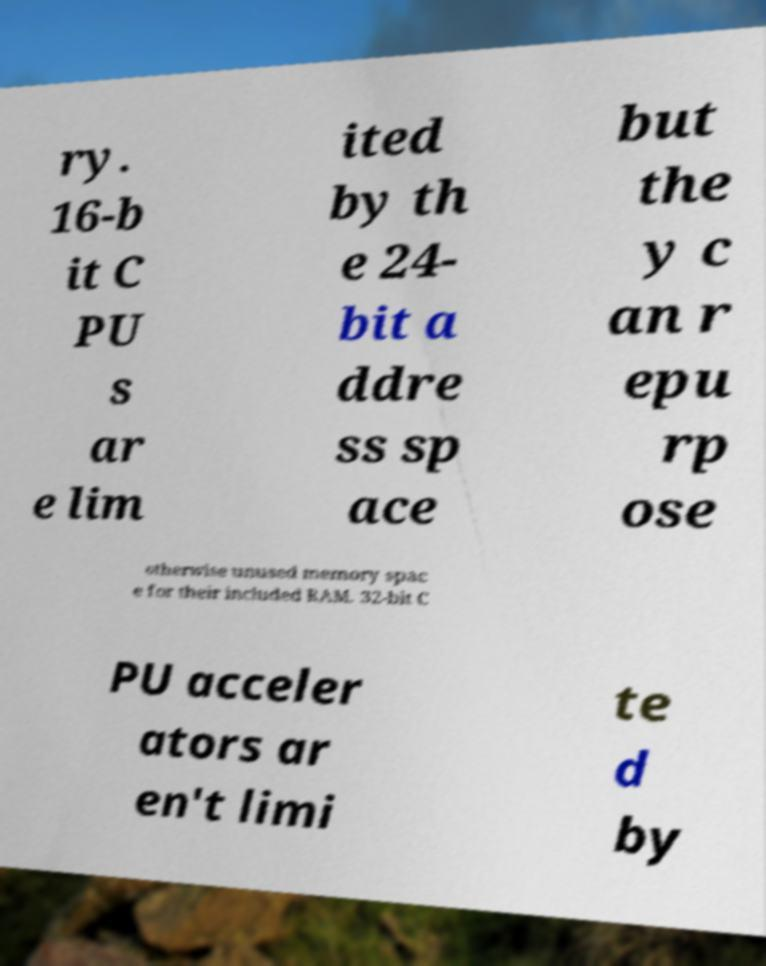I need the written content from this picture converted into text. Can you do that? ry. 16-b it C PU s ar e lim ited by th e 24- bit a ddre ss sp ace but the y c an r epu rp ose otherwise unused memory spac e for their included RAM. 32-bit C PU acceler ators ar en't limi te d by 